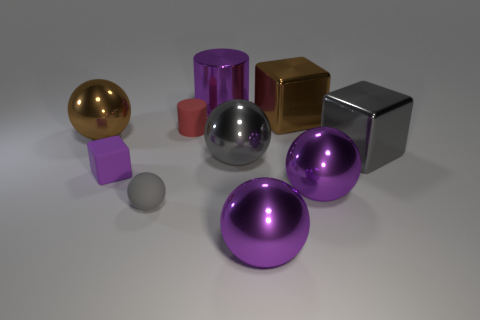Subtract all small matte balls. How many balls are left? 4 Subtract all brown spheres. How many spheres are left? 4 Subtract 3 balls. How many balls are left? 2 Subtract all green balls. Subtract all blue cylinders. How many balls are left? 5 Subtract all cylinders. How many objects are left? 8 Add 3 tiny gray matte objects. How many tiny gray matte objects exist? 4 Subtract 0 green cylinders. How many objects are left? 10 Subtract all rubber cubes. Subtract all small red matte cylinders. How many objects are left? 8 Add 3 big purple metallic balls. How many big purple metallic balls are left? 5 